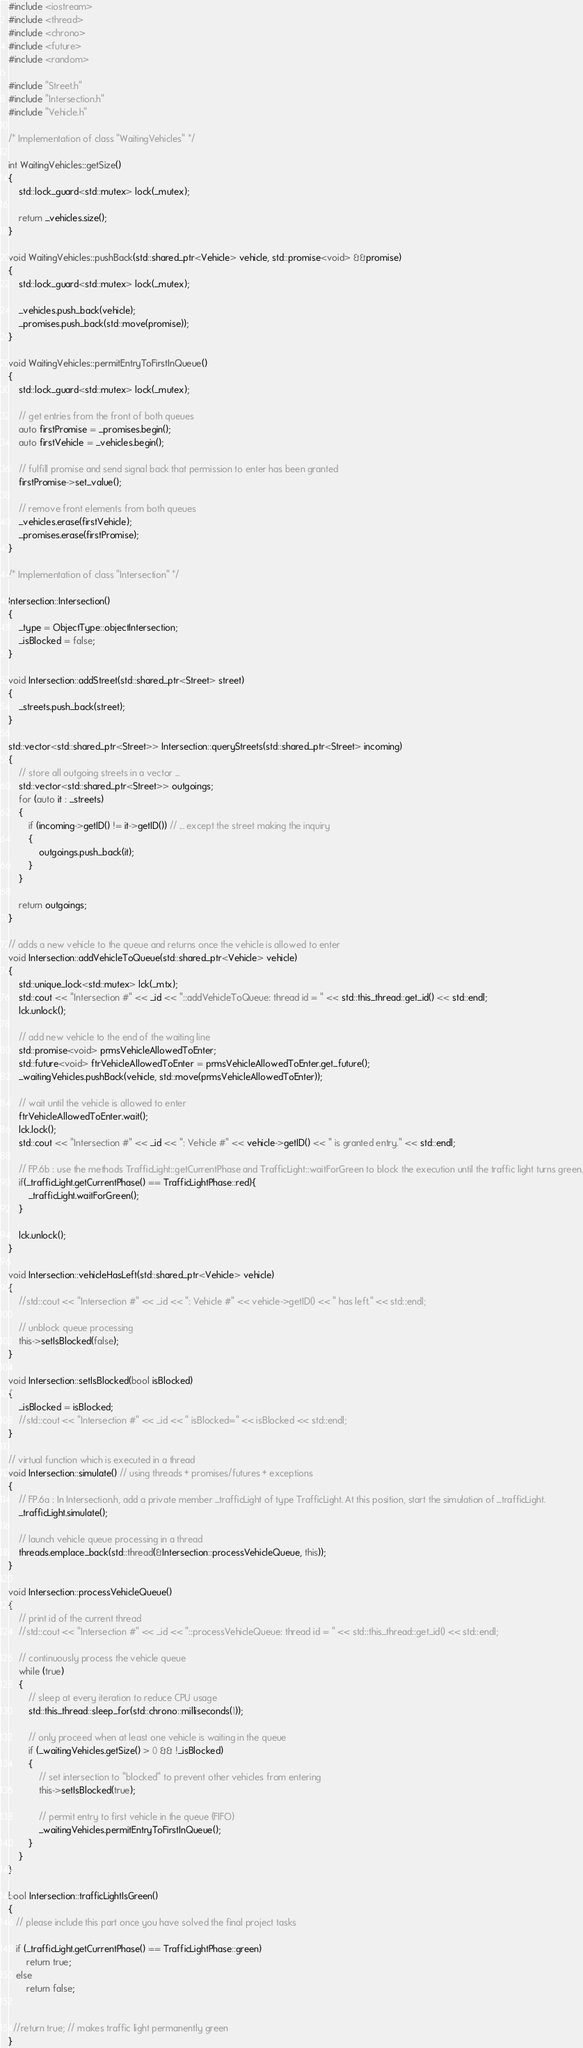Convert code to text. <code><loc_0><loc_0><loc_500><loc_500><_C++_>#include <iostream>
#include <thread>
#include <chrono>
#include <future>
#include <random>

#include "Street.h"
#include "Intersection.h"
#include "Vehicle.h"

/* Implementation of class "WaitingVehicles" */

int WaitingVehicles::getSize()
{
    std::lock_guard<std::mutex> lock(_mutex);

    return _vehicles.size();
}

void WaitingVehicles::pushBack(std::shared_ptr<Vehicle> vehicle, std::promise<void> &&promise)
{
    std::lock_guard<std::mutex> lock(_mutex);

    _vehicles.push_back(vehicle);
    _promises.push_back(std::move(promise));
}

void WaitingVehicles::permitEntryToFirstInQueue()
{
    std::lock_guard<std::mutex> lock(_mutex);

    // get entries from the front of both queues
    auto firstPromise = _promises.begin();
    auto firstVehicle = _vehicles.begin();

    // fulfill promise and send signal back that permission to enter has been granted
    firstPromise->set_value();

    // remove front elements from both queues
    _vehicles.erase(firstVehicle);
    _promises.erase(firstPromise);
}

/* Implementation of class "Intersection" */

Intersection::Intersection()
{
    _type = ObjectType::objectIntersection;
    _isBlocked = false;
}

void Intersection::addStreet(std::shared_ptr<Street> street)
{
    _streets.push_back(street);
}

std::vector<std::shared_ptr<Street>> Intersection::queryStreets(std::shared_ptr<Street> incoming)
{
    // store all outgoing streets in a vector ...
    std::vector<std::shared_ptr<Street>> outgoings;
    for (auto it : _streets)
    {
        if (incoming->getID() != it->getID()) // ... except the street making the inquiry
        {
            outgoings.push_back(it);
        }
    }

    return outgoings;
}

// adds a new vehicle to the queue and returns once the vehicle is allowed to enter
void Intersection::addVehicleToQueue(std::shared_ptr<Vehicle> vehicle)
{
    std::unique_lock<std::mutex> lck(_mtx);
    std::cout << "Intersection #" << _id << "::addVehicleToQueue: thread id = " << std::this_thread::get_id() << std::endl;
    lck.unlock();

    // add new vehicle to the end of the waiting line
    std::promise<void> prmsVehicleAllowedToEnter;
    std::future<void> ftrVehicleAllowedToEnter = prmsVehicleAllowedToEnter.get_future();
    _waitingVehicles.pushBack(vehicle, std::move(prmsVehicleAllowedToEnter));

    // wait until the vehicle is allowed to enter
    ftrVehicleAllowedToEnter.wait();
    lck.lock();
    std::cout << "Intersection #" << _id << ": Vehicle #" << vehicle->getID() << " is granted entry." << std::endl;
    
    // FP.6b : use the methods TrafficLight::getCurrentPhase and TrafficLight::waitForGreen to block the execution until the traffic light turns green.
    if(_trafficLight.getCurrentPhase() == TrafficLightPhase::red){
        _trafficLight.waitForGreen();
    }

    lck.unlock();
}

void Intersection::vehicleHasLeft(std::shared_ptr<Vehicle> vehicle)
{
    //std::cout << "Intersection #" << _id << ": Vehicle #" << vehicle->getID() << " has left." << std::endl;

    // unblock queue processing
    this->setIsBlocked(false);
}

void Intersection::setIsBlocked(bool isBlocked)
{
    _isBlocked = isBlocked;
    //std::cout << "Intersection #" << _id << " isBlocked=" << isBlocked << std::endl;
}

// virtual function which is executed in a thread
void Intersection::simulate() // using threads + promises/futures + exceptions
{
    // FP.6a : In Intersection.h, add a private member _trafficLight of type TrafficLight. At this position, start the simulation of _trafficLight.
    _trafficLight.simulate();

    // launch vehicle queue processing in a thread
    threads.emplace_back(std::thread(&Intersection::processVehicleQueue, this));
}

void Intersection::processVehicleQueue()
{
    // print id of the current thread
    //std::cout << "Intersection #" << _id << "::processVehicleQueue: thread id = " << std::this_thread::get_id() << std::endl;

    // continuously process the vehicle queue
    while (true)
    {
        // sleep at every iteration to reduce CPU usage
        std::this_thread::sleep_for(std::chrono::milliseconds(1));

        // only proceed when at least one vehicle is waiting in the queue
        if (_waitingVehicles.getSize() > 0 && !_isBlocked)
        {
            // set intersection to "blocked" to prevent other vehicles from entering
            this->setIsBlocked(true);

            // permit entry to first vehicle in the queue (FIFO)
            _waitingVehicles.permitEntryToFirstInQueue();
        }
    }
}

bool Intersection::trafficLightIsGreen()
{
   // please include this part once you have solved the final project tasks
   
   if (_trafficLight.getCurrentPhase() == TrafficLightPhase::green)
       return true;
   else
       return false;
   

  //return true; // makes traffic light permanently green
} </code> 